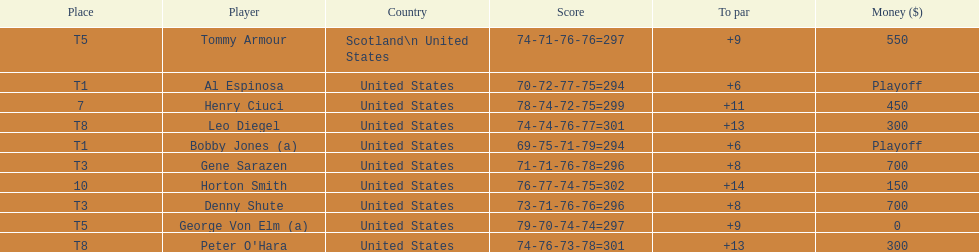Which two players tied for first place? Bobby Jones (a), Al Espinosa. 